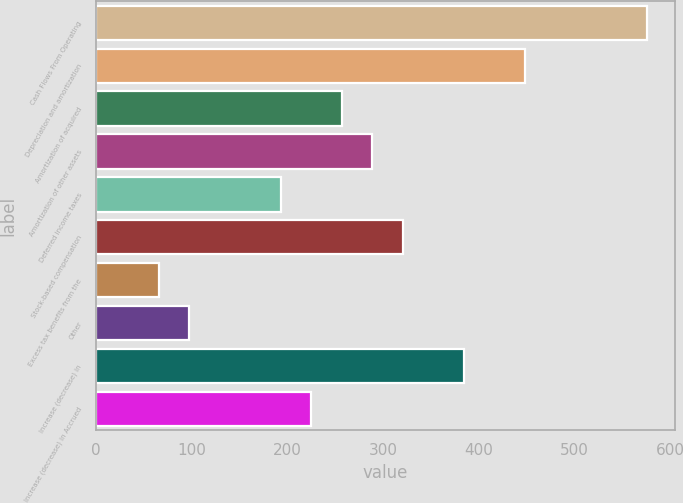Convert chart to OTSL. <chart><loc_0><loc_0><loc_500><loc_500><bar_chart><fcel>Cash Flows From Operating<fcel>Depreciation and amortization<fcel>Amortization of acquired<fcel>Amortization of other assets<fcel>Deferred income taxes<fcel>Stock-based compensation<fcel>Excess tax benefits from the<fcel>Other<fcel>Increase (decrease) in<fcel>Increase (decrease) in Accrued<nl><fcel>575.78<fcel>448.14<fcel>256.68<fcel>288.59<fcel>192.86<fcel>320.5<fcel>65.22<fcel>97.13<fcel>384.32<fcel>224.77<nl></chart> 